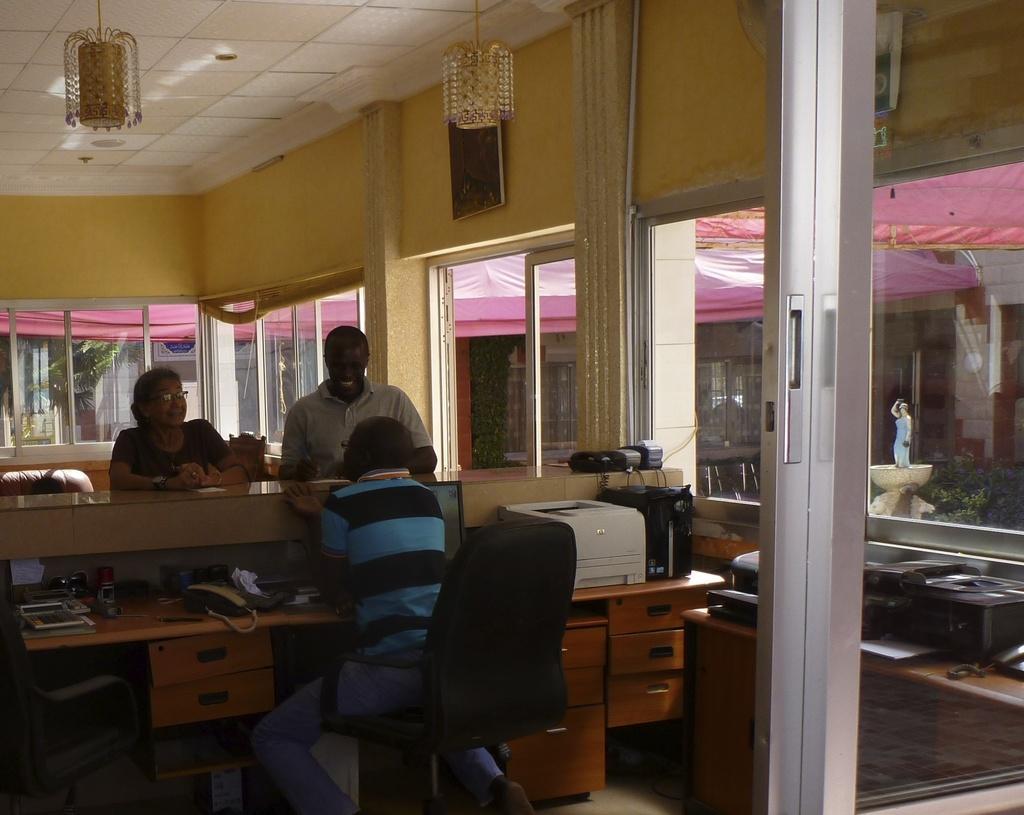In one or two sentences, can you explain what this image depicts? It is a room it looks like a reception ,one person wearing blue and black shirt is sitting and talking to the people who are standing in front of him ,there is table and on the table there is a monitor, printer ,some books, a telephone ,in the background there are some windows and outside that there is a pink color tint. 